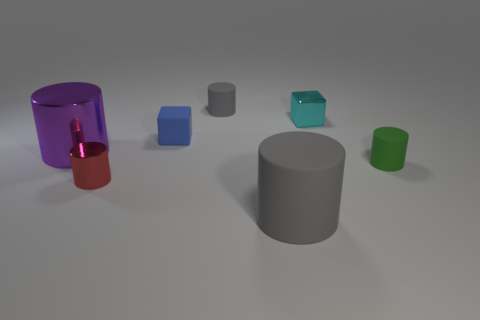Does the tiny blue object have the same material as the small cylinder that is right of the large gray thing?
Your answer should be compact. Yes. Are there more matte objects behind the purple cylinder than big green things?
Provide a succinct answer. Yes. Do the small metal cylinder and the shiny cylinder that is left of the red metal cylinder have the same color?
Provide a short and direct response. No. Is the number of green cylinders that are on the right side of the metallic cube the same as the number of small rubber blocks that are in front of the tiny shiny cylinder?
Your answer should be compact. No. What is the big object right of the large purple cylinder made of?
Your answer should be very brief. Rubber. What number of things are gray rubber objects that are in front of the small red cylinder or big cyan shiny things?
Offer a very short reply. 1. What number of other objects are the same shape as the small gray rubber object?
Your response must be concise. 4. Does the large thing that is to the left of the small blue matte block have the same shape as the blue matte object?
Your response must be concise. No. There is a small metallic cube; are there any shiny things on the left side of it?
Give a very brief answer. Yes. How many tiny objects are either gray cylinders or green matte things?
Your answer should be very brief. 2. 